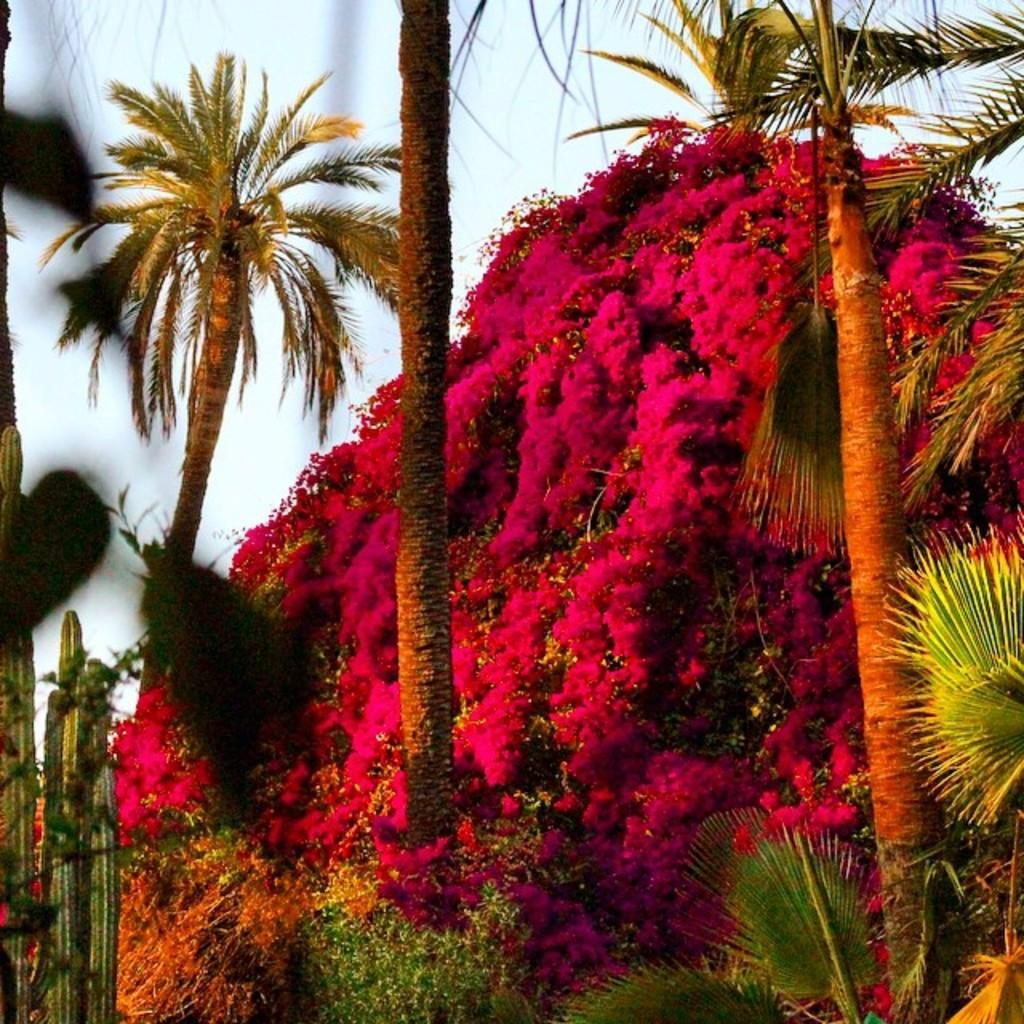What type of living organisms can be seen in the image? Plants, flowers, and trees are visible in the image. What can be seen in the background of the image? The sky is visible in the background of the image. What type of egg is being used by the creator in the image? There is no egg or creator present in the image; it features plants, flowers, trees, and the sky. What type of notebook is being used by the person in the image? There is no person or notebook present in the image. 